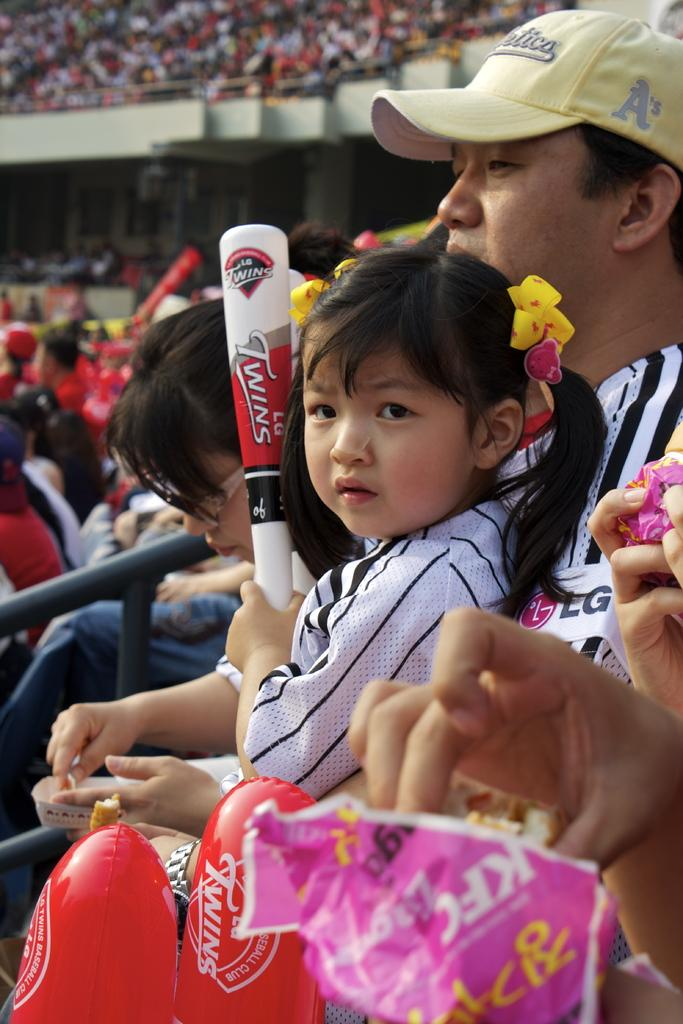How many individuals are present in the image? There are many people in the image. What are the people doing in the image? The people are sitting on stairs. What type of collar can be seen on the light in the image? There is no light or collar present in the image; it features many people sitting on stairs. 